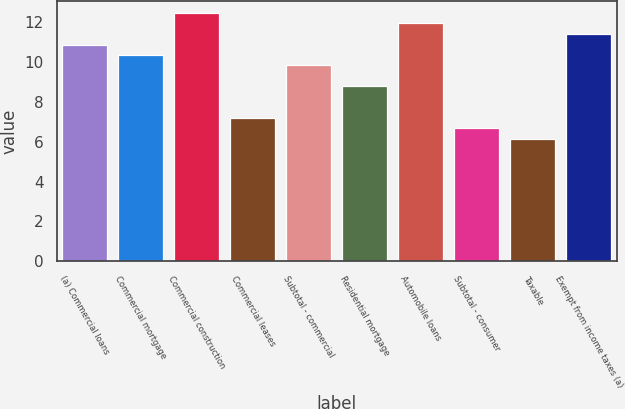Convert chart to OTSL. <chart><loc_0><loc_0><loc_500><loc_500><bar_chart><fcel>(a) Commercial loans<fcel>Commercial mortgage<fcel>Commercial construction<fcel>Commercial leases<fcel>Subtotal - commercial<fcel>Residential mortgage<fcel>Automobile loans<fcel>Subtotal - consumer<fcel>Taxable<fcel>Exempt from income taxes (a)<nl><fcel>10.89<fcel>10.37<fcel>12.47<fcel>7.2<fcel>9.84<fcel>8.79<fcel>11.95<fcel>6.67<fcel>6.14<fcel>11.42<nl></chart> 